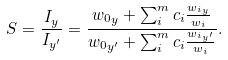Convert formula to latex. <formula><loc_0><loc_0><loc_500><loc_500>S = \frac { I _ { y } } { I _ { y ^ { \prime } } } = \frac { { w _ { 0 } } _ { y } + \sum _ { i } ^ { m } c _ { i } \frac { { w _ { i } } _ { y } } { w _ { i } } } { { w _ { 0 } } _ { y ^ { \prime } } + \sum _ { i } ^ { m } c _ { i } \frac { { w _ { i } } _ { y ^ { \prime } } } { w _ { i } } } .</formula> 